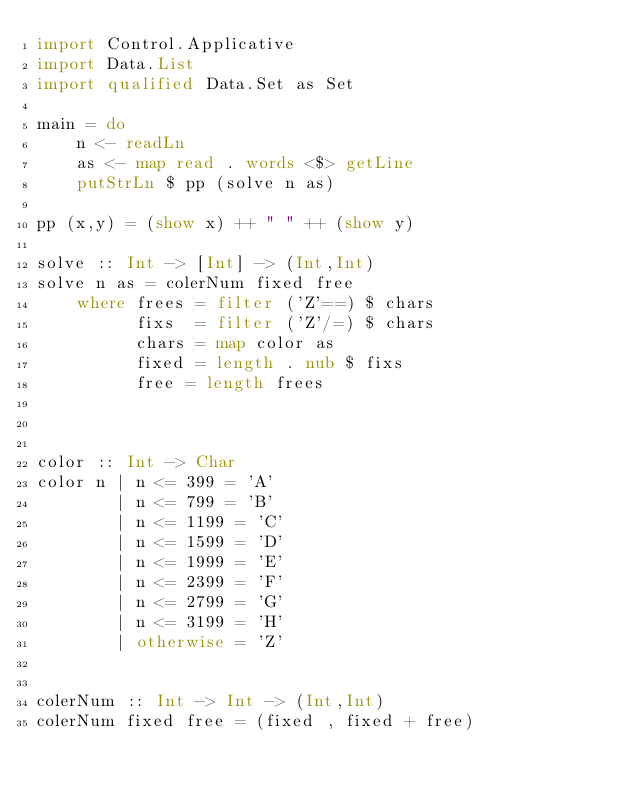<code> <loc_0><loc_0><loc_500><loc_500><_Haskell_>import Control.Applicative
import Data.List
import qualified Data.Set as Set

main = do
    n <- readLn
    as <- map read . words <$> getLine
    putStrLn $ pp (solve n as)

pp (x,y) = (show x) ++ " " ++ (show y)

solve :: Int -> [Int] -> (Int,Int)
solve n as = colerNum fixed free
    where frees = filter ('Z'==) $ chars
          fixs  = filter ('Z'/=) $ chars
          chars = map color as
          fixed = length . nub $ fixs
          free = length frees



color :: Int -> Char
color n | n <= 399 = 'A'
        | n <= 799 = 'B'
        | n <= 1199 = 'C'
        | n <= 1599 = 'D'
        | n <= 1999 = 'E'
        | n <= 2399 = 'F'
        | n <= 2799 = 'G'
        | n <= 3199 = 'H'
        | otherwise = 'Z'
        

colerNum :: Int -> Int -> (Int,Int)
colerNum fixed free = (fixed , fixed + free)
</code> 